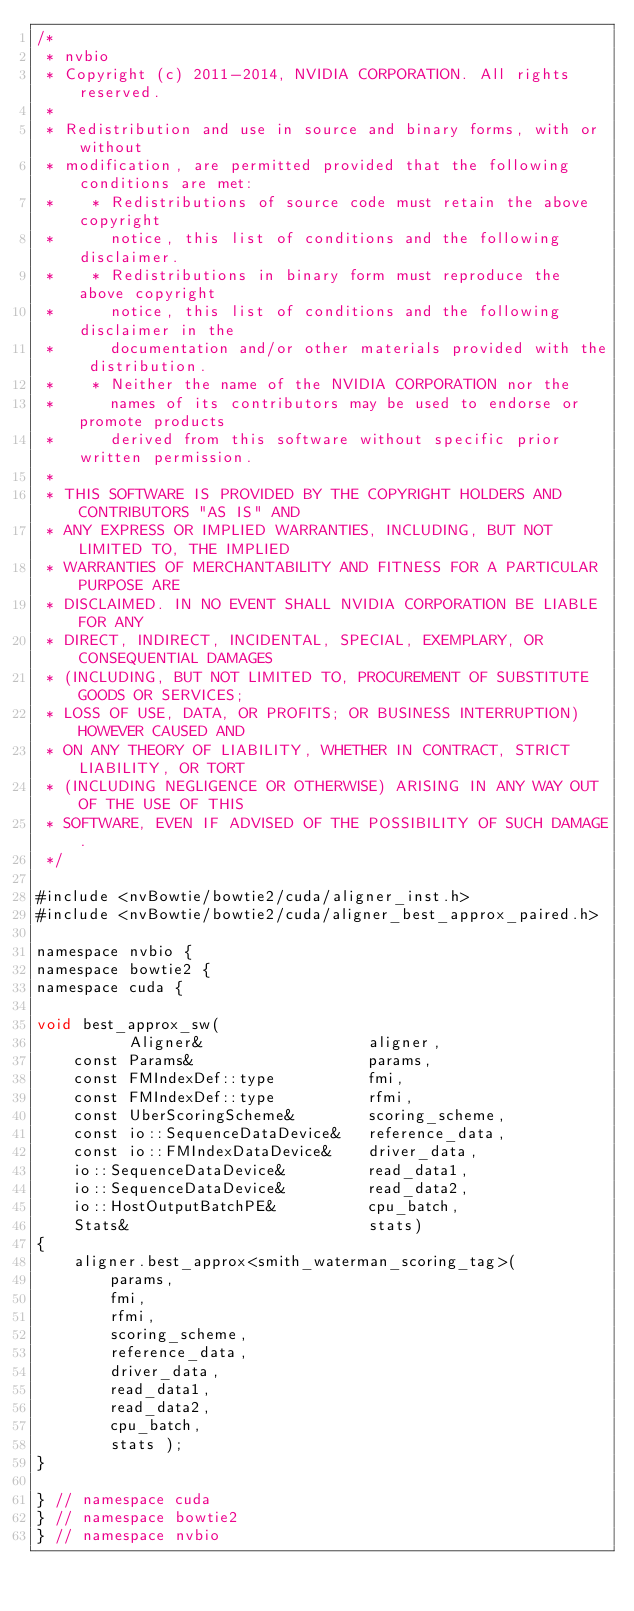<code> <loc_0><loc_0><loc_500><loc_500><_Cuda_>/*
 * nvbio
 * Copyright (c) 2011-2014, NVIDIA CORPORATION. All rights reserved.
 * 
 * Redistribution and use in source and binary forms, with or without
 * modification, are permitted provided that the following conditions are met:
 *    * Redistributions of source code must retain the above copyright
 *      notice, this list of conditions and the following disclaimer.
 *    * Redistributions in binary form must reproduce the above copyright
 *      notice, this list of conditions and the following disclaimer in the
 *      documentation and/or other materials provided with the distribution.
 *    * Neither the name of the NVIDIA CORPORATION nor the
 *      names of its contributors may be used to endorse or promote products
 *      derived from this software without specific prior written permission.
 * 
 * THIS SOFTWARE IS PROVIDED BY THE COPYRIGHT HOLDERS AND CONTRIBUTORS "AS IS" AND
 * ANY EXPRESS OR IMPLIED WARRANTIES, INCLUDING, BUT NOT LIMITED TO, THE IMPLIED
 * WARRANTIES OF MERCHANTABILITY AND FITNESS FOR A PARTICULAR PURPOSE ARE
 * DISCLAIMED. IN NO EVENT SHALL NVIDIA CORPORATION BE LIABLE FOR ANY
 * DIRECT, INDIRECT, INCIDENTAL, SPECIAL, EXEMPLARY, OR CONSEQUENTIAL DAMAGES
 * (INCLUDING, BUT NOT LIMITED TO, PROCUREMENT OF SUBSTITUTE GOODS OR SERVICES;
 * LOSS OF USE, DATA, OR PROFITS; OR BUSINESS INTERRUPTION) HOWEVER CAUSED AND
 * ON ANY THEORY OF LIABILITY, WHETHER IN CONTRACT, STRICT LIABILITY, OR TORT
 * (INCLUDING NEGLIGENCE OR OTHERWISE) ARISING IN ANY WAY OUT OF THE USE OF THIS
 * SOFTWARE, EVEN IF ADVISED OF THE POSSIBILITY OF SUCH DAMAGE.
 */

#include <nvBowtie/bowtie2/cuda/aligner_inst.h>
#include <nvBowtie/bowtie2/cuda/aligner_best_approx_paired.h>

namespace nvbio {
namespace bowtie2 {
namespace cuda {

void best_approx_sw(
          Aligner&                  aligner,
    const Params&                   params,
    const FMIndexDef::type          fmi,
    const FMIndexDef::type          rfmi,
    const UberScoringScheme&        scoring_scheme,
    const io::SequenceDataDevice&   reference_data,
    const io::FMIndexDataDevice&    driver_data,
    io::SequenceDataDevice&         read_data1,
    io::SequenceDataDevice&         read_data2,
    io::HostOutputBatchPE&          cpu_batch,
    Stats&                          stats)
{
    aligner.best_approx<smith_waterman_scoring_tag>(
        params,
        fmi,
        rfmi,
        scoring_scheme,
        reference_data,
        driver_data,
        read_data1,
        read_data2,
        cpu_batch,
        stats );
}

} // namespace cuda
} // namespace bowtie2
} // namespace nvbio
</code> 